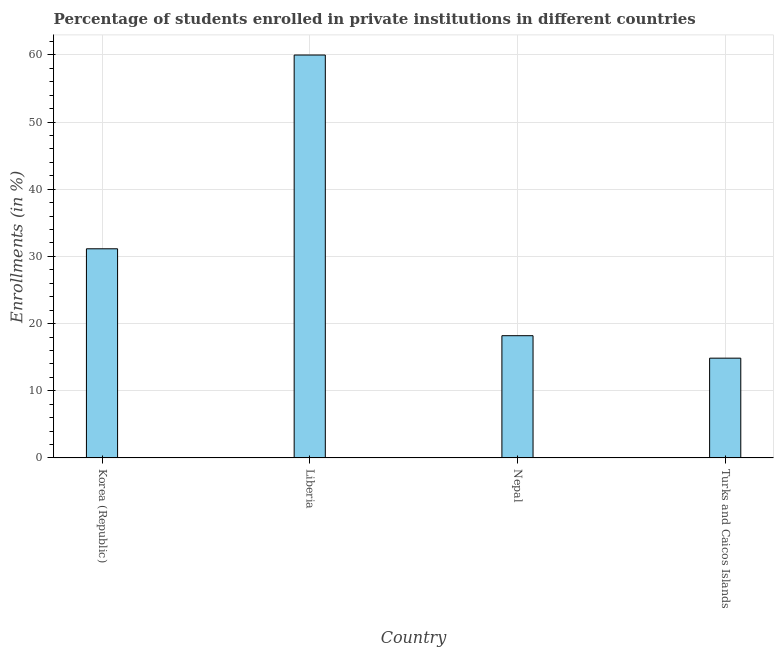What is the title of the graph?
Keep it short and to the point. Percentage of students enrolled in private institutions in different countries. What is the label or title of the X-axis?
Ensure brevity in your answer.  Country. What is the label or title of the Y-axis?
Offer a terse response. Enrollments (in %). What is the enrollments in private institutions in Liberia?
Provide a succinct answer. 59.98. Across all countries, what is the maximum enrollments in private institutions?
Your answer should be compact. 59.98. Across all countries, what is the minimum enrollments in private institutions?
Provide a succinct answer. 14.85. In which country was the enrollments in private institutions maximum?
Provide a succinct answer. Liberia. In which country was the enrollments in private institutions minimum?
Offer a very short reply. Turks and Caicos Islands. What is the sum of the enrollments in private institutions?
Your answer should be very brief. 124.17. What is the difference between the enrollments in private institutions in Liberia and Nepal?
Keep it short and to the point. 41.78. What is the average enrollments in private institutions per country?
Offer a very short reply. 31.04. What is the median enrollments in private institutions?
Offer a very short reply. 24.67. What is the ratio of the enrollments in private institutions in Korea (Republic) to that in Nepal?
Ensure brevity in your answer.  1.71. Is the enrollments in private institutions in Liberia less than that in Nepal?
Your answer should be very brief. No. Is the difference between the enrollments in private institutions in Korea (Republic) and Turks and Caicos Islands greater than the difference between any two countries?
Your answer should be compact. No. What is the difference between the highest and the second highest enrollments in private institutions?
Your answer should be very brief. 28.84. What is the difference between the highest and the lowest enrollments in private institutions?
Your answer should be compact. 45.13. In how many countries, is the enrollments in private institutions greater than the average enrollments in private institutions taken over all countries?
Make the answer very short. 2. How many countries are there in the graph?
Ensure brevity in your answer.  4. Are the values on the major ticks of Y-axis written in scientific E-notation?
Make the answer very short. No. What is the Enrollments (in %) of Korea (Republic)?
Offer a terse response. 31.14. What is the Enrollments (in %) in Liberia?
Your answer should be compact. 59.98. What is the Enrollments (in %) of Nepal?
Keep it short and to the point. 18.2. What is the Enrollments (in %) of Turks and Caicos Islands?
Your answer should be very brief. 14.85. What is the difference between the Enrollments (in %) in Korea (Republic) and Liberia?
Your answer should be very brief. -28.85. What is the difference between the Enrollments (in %) in Korea (Republic) and Nepal?
Your response must be concise. 12.94. What is the difference between the Enrollments (in %) in Korea (Republic) and Turks and Caicos Islands?
Provide a short and direct response. 16.28. What is the difference between the Enrollments (in %) in Liberia and Nepal?
Make the answer very short. 41.78. What is the difference between the Enrollments (in %) in Liberia and Turks and Caicos Islands?
Your response must be concise. 45.13. What is the difference between the Enrollments (in %) in Nepal and Turks and Caicos Islands?
Provide a short and direct response. 3.34. What is the ratio of the Enrollments (in %) in Korea (Republic) to that in Liberia?
Keep it short and to the point. 0.52. What is the ratio of the Enrollments (in %) in Korea (Republic) to that in Nepal?
Offer a terse response. 1.71. What is the ratio of the Enrollments (in %) in Korea (Republic) to that in Turks and Caicos Islands?
Ensure brevity in your answer.  2.1. What is the ratio of the Enrollments (in %) in Liberia to that in Nepal?
Ensure brevity in your answer.  3.3. What is the ratio of the Enrollments (in %) in Liberia to that in Turks and Caicos Islands?
Your answer should be very brief. 4.04. What is the ratio of the Enrollments (in %) in Nepal to that in Turks and Caicos Islands?
Provide a short and direct response. 1.23. 